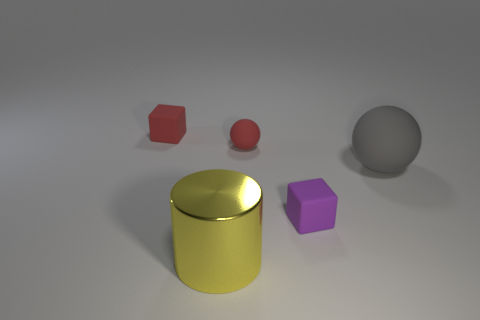Is the big sphere the same color as the tiny rubber ball?
Provide a short and direct response. No. There is a red cube that is the same size as the red ball; what is it made of?
Your response must be concise. Rubber. Do the large yellow object and the purple object have the same material?
Keep it short and to the point. No. Is the number of matte balls that are behind the gray object greater than the number of things that are behind the large yellow metal thing?
Your answer should be very brief. No. There is a sphere in front of the small red thing in front of the rubber cube left of the small red sphere; what color is it?
Make the answer very short. Gray. How many other objects are the same color as the large matte thing?
Your answer should be very brief. 0. What number of matte objects are yellow things or small green cubes?
Ensure brevity in your answer.  0. Does the cube that is in front of the red cube have the same color as the block that is behind the large matte ball?
Your answer should be very brief. No. Is there anything else that is made of the same material as the big yellow thing?
Make the answer very short. No. There is a red object that is the same shape as the purple rubber thing; what size is it?
Offer a very short reply. Small. 